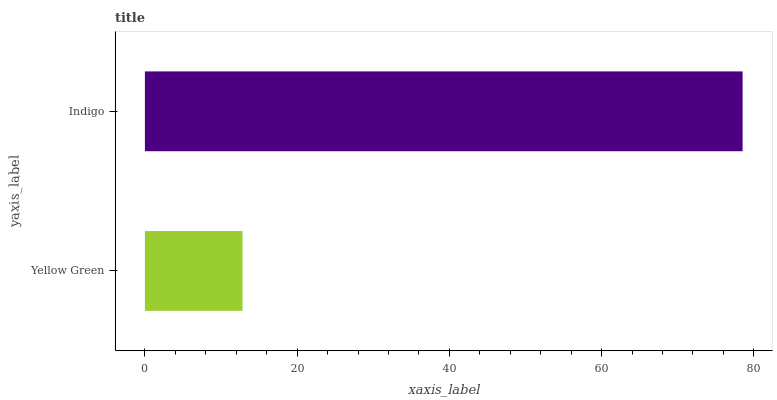Is Yellow Green the minimum?
Answer yes or no. Yes. Is Indigo the maximum?
Answer yes or no. Yes. Is Indigo the minimum?
Answer yes or no. No. Is Indigo greater than Yellow Green?
Answer yes or no. Yes. Is Yellow Green less than Indigo?
Answer yes or no. Yes. Is Yellow Green greater than Indigo?
Answer yes or no. No. Is Indigo less than Yellow Green?
Answer yes or no. No. Is Indigo the high median?
Answer yes or no. Yes. Is Yellow Green the low median?
Answer yes or no. Yes. Is Yellow Green the high median?
Answer yes or no. No. Is Indigo the low median?
Answer yes or no. No. 